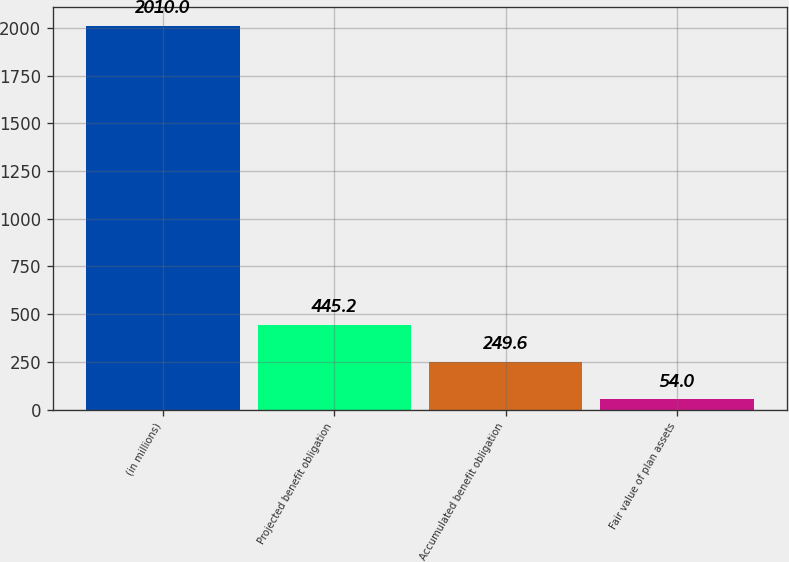Convert chart. <chart><loc_0><loc_0><loc_500><loc_500><bar_chart><fcel>(in millions)<fcel>Projected benefit obligation<fcel>Accumulated benefit obligation<fcel>Fair value of plan assets<nl><fcel>2010<fcel>445.2<fcel>249.6<fcel>54<nl></chart> 